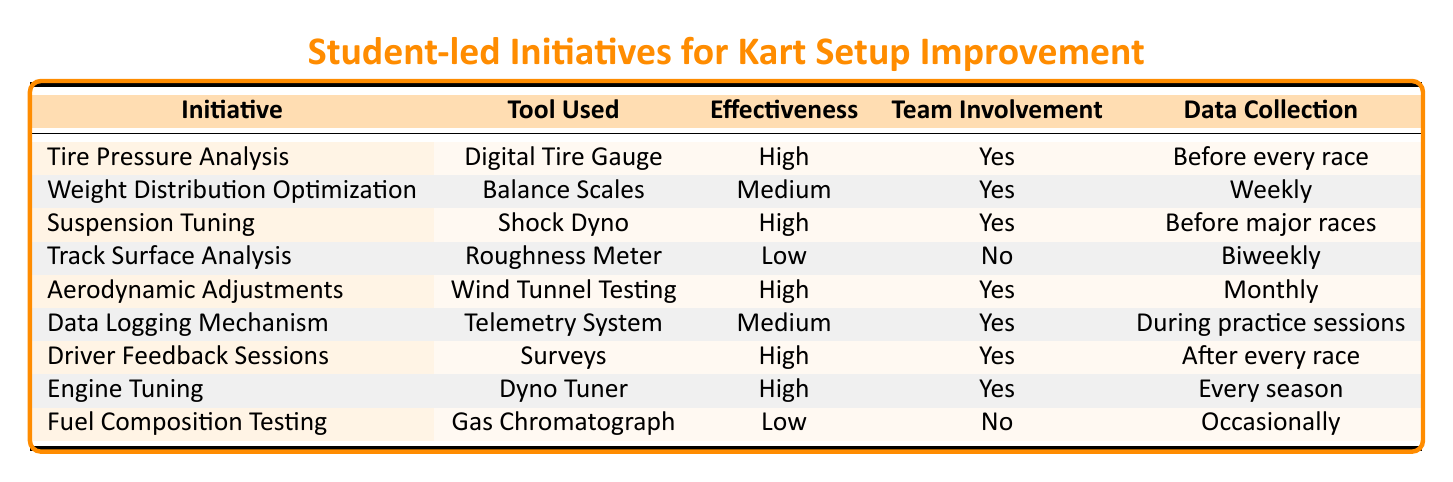What is the effectiveness level of Tire Pressure Analysis? According to the table, the effectiveness of Tire Pressure Analysis is labeled as "High."
Answer: High How often is Weight Distribution Optimization data collected? The table indicates that data for Weight Distribution Optimization is collected "Weekly."
Answer: Weekly Is there team member involvement in Track Surface Analysis? The table states that there is "No" team member involvement in Track Surface Analysis.
Answer: No Which initiatives have High effectiveness? By reviewing the table, the initiatives with High effectiveness are Tire Pressure Analysis, Suspension Tuning, Aerodynamic Adjustments, Driver Feedback Sessions, and Engine Tuning.
Answer: Tire Pressure Analysis, Suspension Tuning, Aerodynamic Adjustments, Driver Feedback Sessions, Engine Tuning What is the average effectiveness of all initiatives listed in the table? The initiatives are categorized into three effectiveness levels: High (5), Medium (2), and Low (2). To calculate the average, convert them to numerical values: High = 3, Medium = 2, Low = 1. The average effectiveness calculation is (5*3 + 2*2 + 2*1) / 9 = 23 / 9 = 2.56, which corresponds to Medium effectiveness.
Answer: Medium How many initiatives involve team members? By checking the table, we find that 7 out of 9 initiatives have team member involvement.
Answer: 7 What is the tool used for Aerodynamic Adjustments? The table clearly shows that the tool used for Aerodynamic Adjustments is "Wind Tunnel Testing."
Answer: Wind Tunnel Testing Does Fuel Composition Testing have high effectiveness? Referring to the table, Fuel Composition Testing is listed with "Low" effectiveness, so the answer is no.
Answer: No Which initiative is collected biweekly and has low effectiveness? The table indicates that Track Surface Analysis is the initiative that is collected biweekly and has a "Low" effectiveness rating.
Answer: Track Surface Analysis Are there any initiatives not involving team members? The table lists two initiatives (Track Surface Analysis and Fuel Composition Testing) that do not involve team members, resulting in a "Yes" answer.
Answer: Yes 